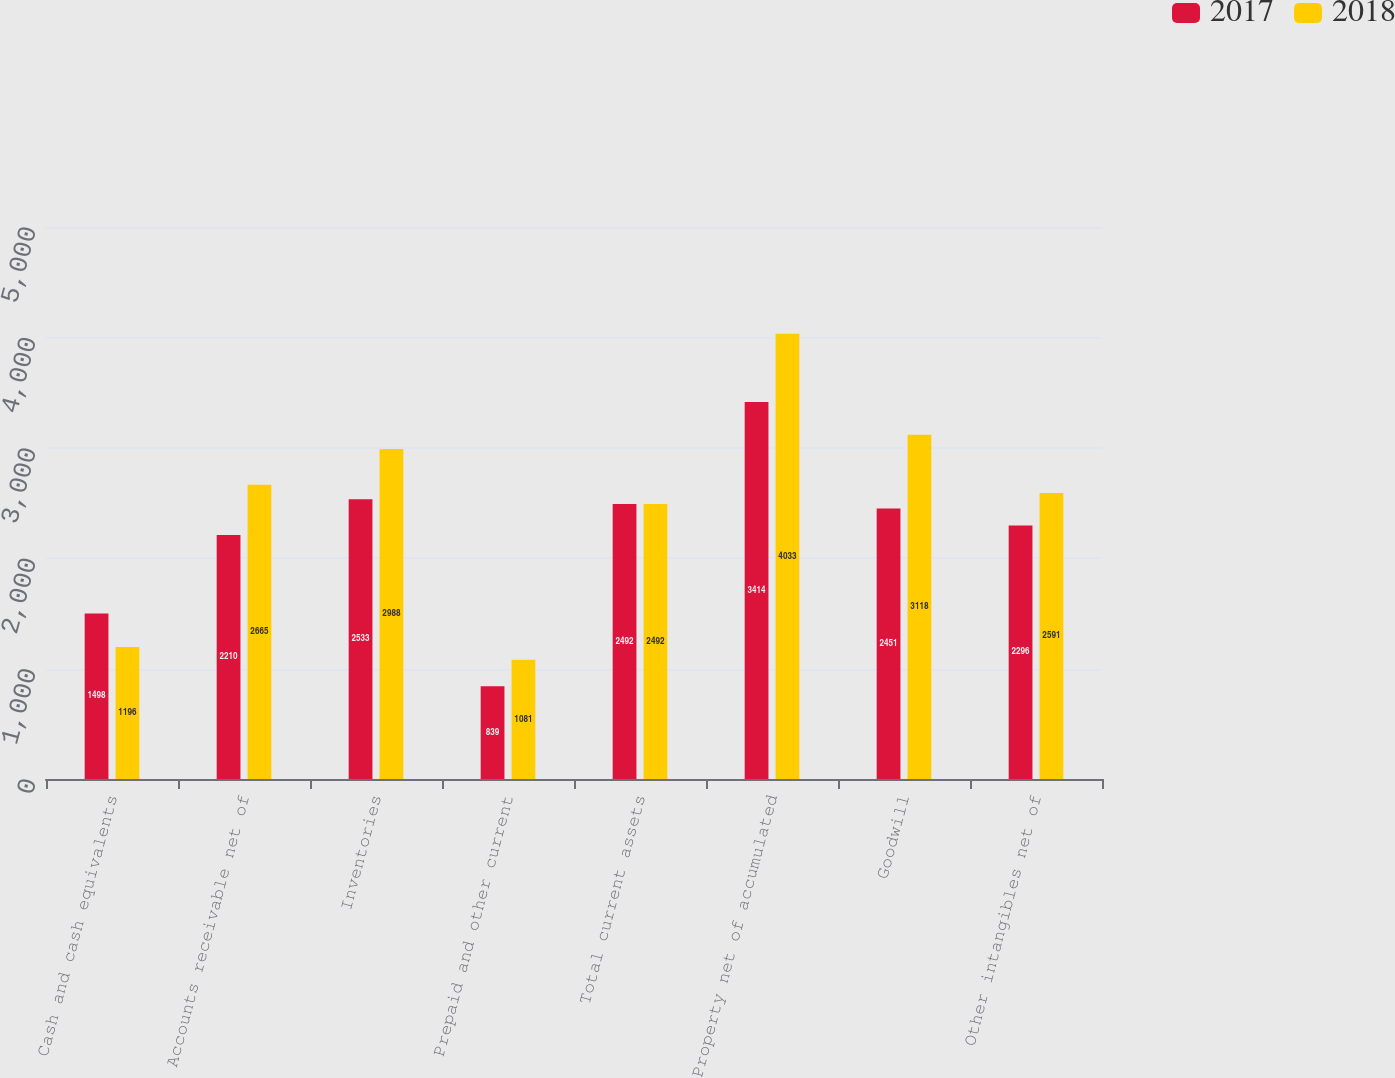<chart> <loc_0><loc_0><loc_500><loc_500><stacked_bar_chart><ecel><fcel>Cash and cash equivalents<fcel>Accounts receivable net of<fcel>Inventories<fcel>Prepaid and other current<fcel>Total current assets<fcel>Property net of accumulated<fcel>Goodwill<fcel>Other intangibles net of<nl><fcel>2017<fcel>1498<fcel>2210<fcel>2533<fcel>839<fcel>2492<fcel>3414<fcel>2451<fcel>2296<nl><fcel>2018<fcel>1196<fcel>2665<fcel>2988<fcel>1081<fcel>2492<fcel>4033<fcel>3118<fcel>2591<nl></chart> 